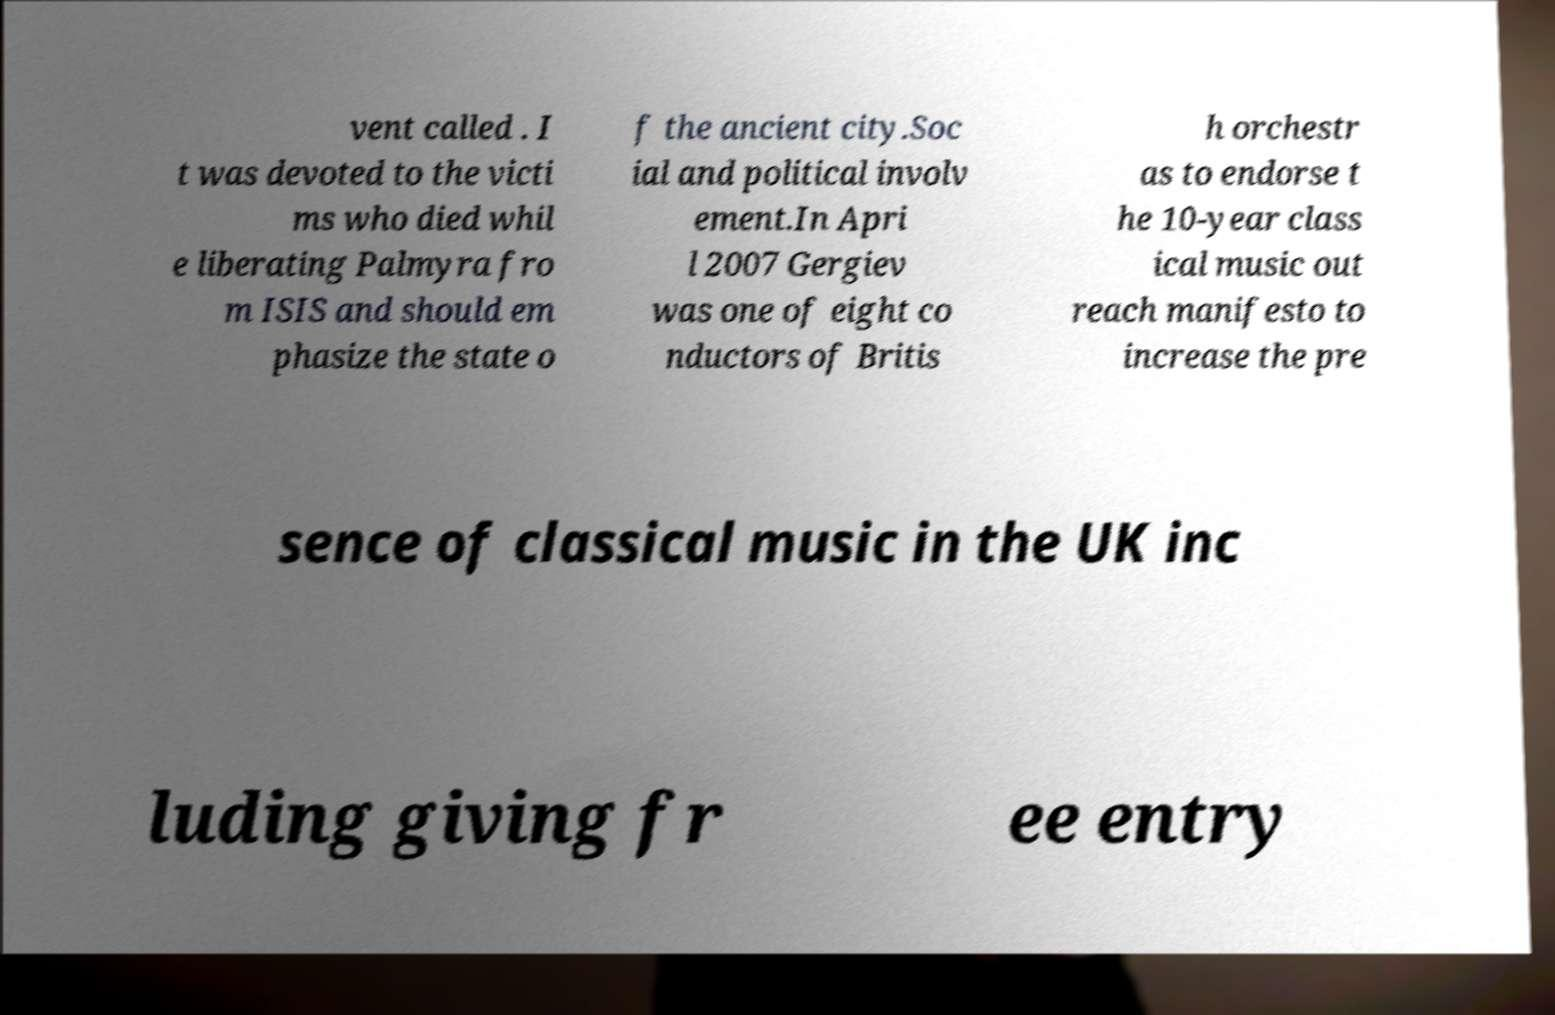Please read and relay the text visible in this image. What does it say? vent called . I t was devoted to the victi ms who died whil e liberating Palmyra fro m ISIS and should em phasize the state o f the ancient city.Soc ial and political involv ement.In Apri l 2007 Gergiev was one of eight co nductors of Britis h orchestr as to endorse t he 10-year class ical music out reach manifesto to increase the pre sence of classical music in the UK inc luding giving fr ee entry 